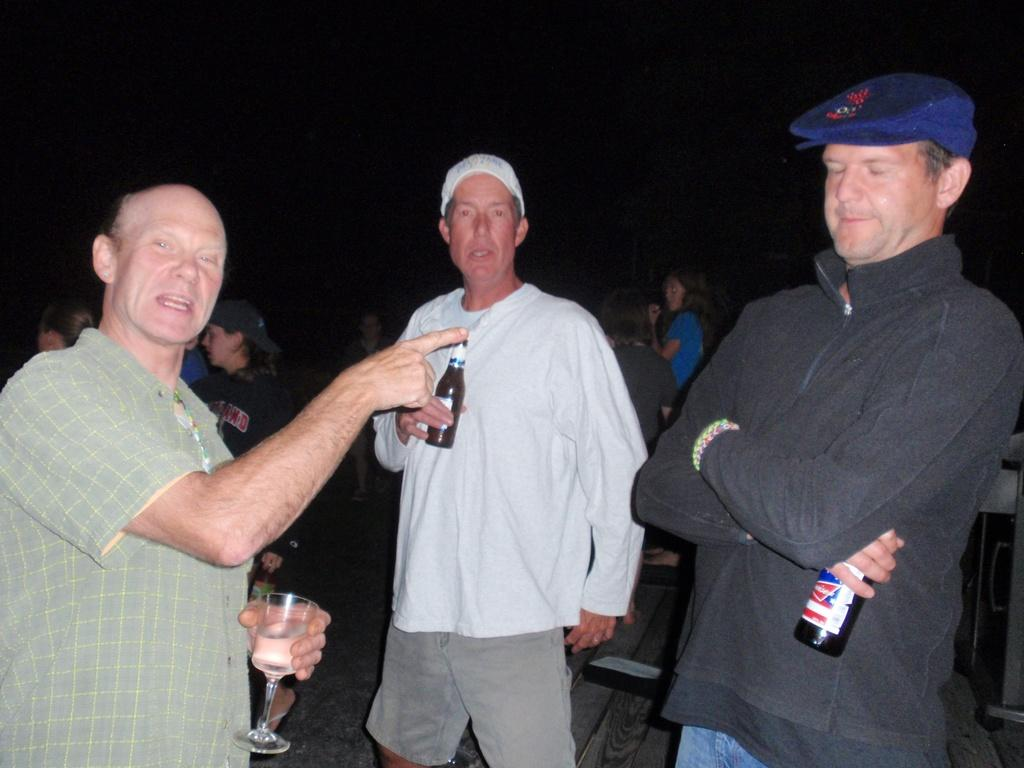How many people are in the image? There are people in the image, but the exact number is not specified. What are the people doing in the image? The people are standing in the image. What type of powder can be seen on the floor in the image? There is no mention of powder in the image, so it cannot be determined if any is present. 